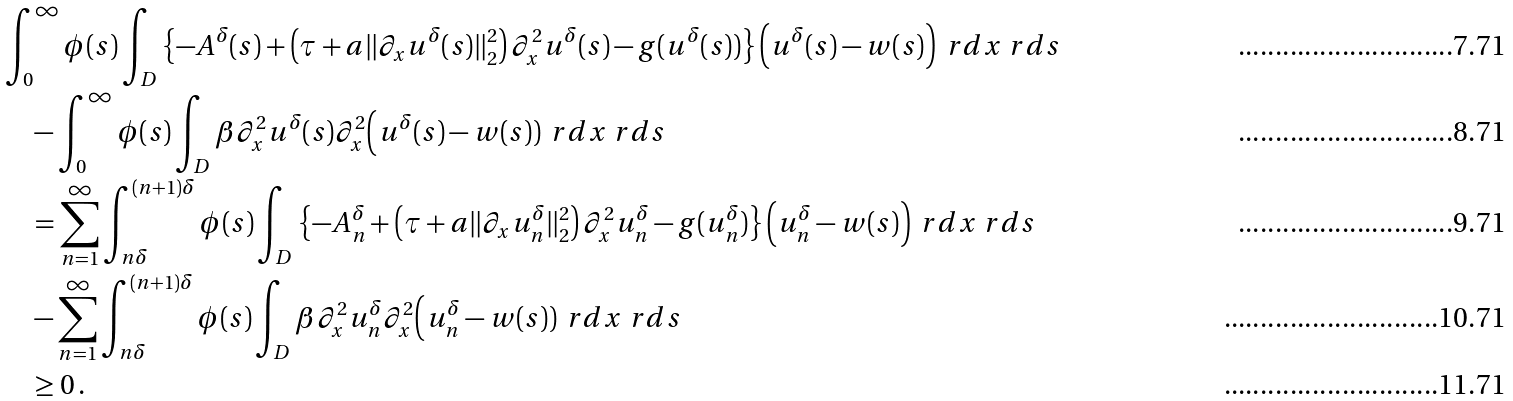Convert formula to latex. <formula><loc_0><loc_0><loc_500><loc_500>& \int _ { 0 } ^ { \infty } \phi ( s ) \int _ { D } \left \{ - A ^ { \delta } ( s ) + \left ( \tau + a \| \partial _ { x } u ^ { \delta } ( s ) \| _ { 2 } ^ { 2 } \right ) \partial _ { x } ^ { 2 } u ^ { \delta } ( s ) - g ( u ^ { \delta } ( s ) ) \right \} \Big ( u ^ { \delta } ( s ) - w ( s ) \Big ) \, \ r d x \ r d s \\ & \quad - \int _ { 0 } ^ { \infty } \phi ( s ) \int _ { D } \beta \partial _ { x } ^ { 2 } u ^ { \delta } ( s ) \partial _ { x } ^ { 2 } \Big ( u ^ { \delta } ( s ) - w ( s ) ) \, \ r d x \ r d s \\ & \quad = \sum _ { n = 1 } ^ { \infty } \int _ { n \delta } ^ { ( n + 1 ) \delta } \phi ( s ) \int _ { D } \left \{ - A _ { n } ^ { \delta } + \left ( \tau + a \| \partial _ { x } u _ { n } ^ { \delta } \| _ { 2 } ^ { 2 } \right ) \partial _ { x } ^ { 2 } u _ { n } ^ { \delta } - g ( u _ { n } ^ { \delta } ) \right \} \Big ( u _ { n } ^ { \delta } - w ( s ) \Big ) \, \ r d x \ r d s \\ & \quad - \sum _ { n = 1 } ^ { \infty } \int _ { n \delta } ^ { ( n + 1 ) \delta } \phi ( s ) \int _ { D } \beta \partial _ { x } ^ { 2 } u _ { n } ^ { \delta } \partial _ { x } ^ { 2 } \Big ( u _ { n } ^ { \delta } - w ( s ) ) \, \ r d x \ r d s \\ & \quad \geq 0 \, .</formula> 